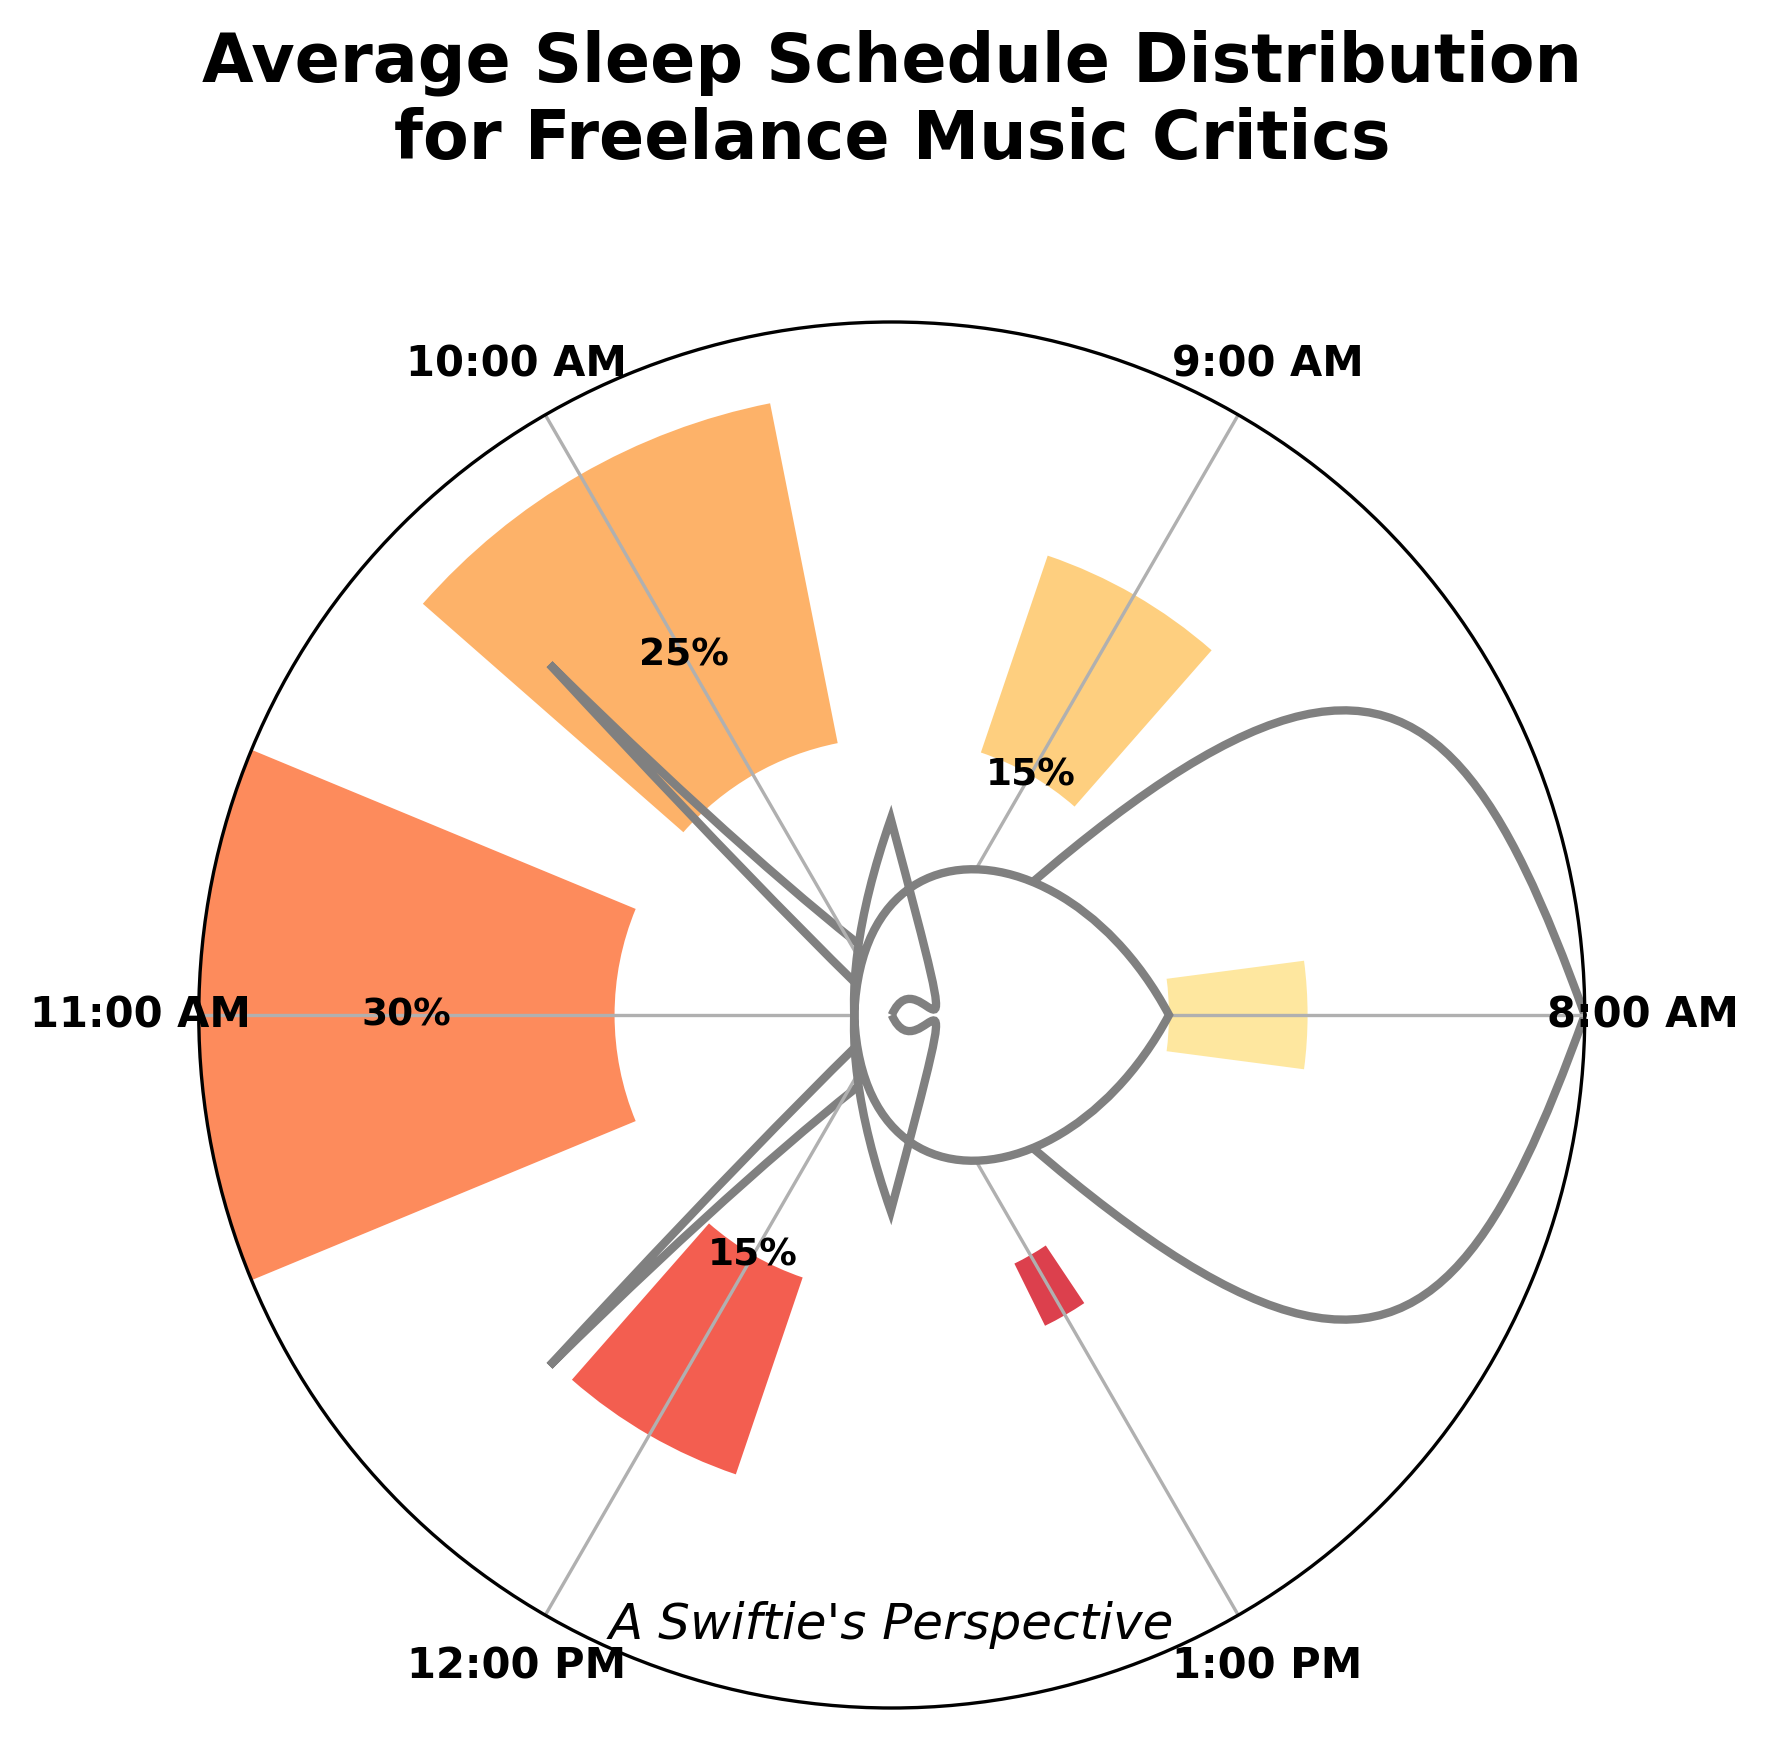Which sleep time has the highest percentage distribution? The highest bar on the plot represents the sleep time with the highest percentage, which is 11:00 AM.
Answer: 11:00 AM What is the percentage of freelance music critics who sleep at 8:00 AM? The label above the bar representing 8:00 AM shows the percentage value.
Answer: 10% How many sleep times have a percentage distribution above 20%? By visually inspecting the bars, the sleep times with percentages above 20% are 10:00 AM and 11:00 AM, making it a total of 2.
Answer: 2 What is the combined percentage of freelance music critics who sleep between 8:00 AM and 9:00 AM? Add the percentages of sleep times at 8:00 AM (10%) and 9:00 AM (15%): 10% + 15%.
Answer: 25% Which sleep time has the lowest percentage distribution? The shortest bar on the plot represents the sleep time with the lowest percentage, which is 1:00 PM.
Answer: 1:00 PM What is the average percentage distribution of sleep times for freelance music critics? Sum all the percentage values and divide by the number of data points: (10 + 15 + 25 + 30 + 15 + 5) / 6 = 100 / 6.
Answer: 16.67% Are there any sleep times with an equal percentage distribution? By comparing the height and labels of the bars, 9:00 AM and 12:00 PM both have a percentage distribution of 15%.
Answer: Yes How much higher is the percentage of critics who sleep at 11:00 AM compared to those who sleep at 1:00 PM? Subtract the percentage for 1:00 PM (5%) from the percentage for 11:00 AM (30%): 30% - 5%.
Answer: 25% Which sleep time range represents the high percentage of freelance music critics’ sleep schedules (above 20%)? The sleep times with a distribution above 20% are 10:00 AM (25%) and 11:00 AM (30%).
Answer: 10:00 AM - 11:00 AM What is the most common sleep schedule among freelance music critics? The sleep time with the highest percentage (30%) is 11:00 AM, indicating it is the most common sleep schedule.
Answer: 11:00 AM 